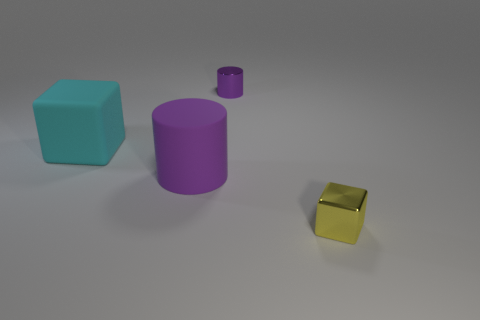Are there any large red rubber blocks?
Give a very brief answer. No. Are there an equal number of cyan things in front of the cyan rubber cube and tiny yellow metal cubes?
Offer a terse response. No. How many other objects are the same shape as the tiny yellow object?
Give a very brief answer. 1. There is a tiny yellow thing; what shape is it?
Your answer should be compact. Cube. Is the material of the cyan thing the same as the tiny cylinder?
Keep it short and to the point. No. Is the number of small purple shiny objects behind the small purple metallic cylinder the same as the number of yellow shiny objects that are behind the matte cylinder?
Make the answer very short. Yes. There is a big cyan rubber block that is in front of the tiny metallic object that is behind the yellow thing; are there any rubber cubes that are behind it?
Offer a very short reply. No. Is the cyan matte thing the same size as the purple shiny thing?
Your answer should be compact. No. What color is the small thing that is to the left of the block on the right side of the small thing that is behind the large cyan matte thing?
Provide a short and direct response. Purple. How many shiny cylinders are the same color as the tiny block?
Keep it short and to the point. 0. 